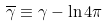Convert formula to latex. <formula><loc_0><loc_0><loc_500><loc_500>\overline { \gamma } \equiv \gamma - \ln 4 \pi</formula> 